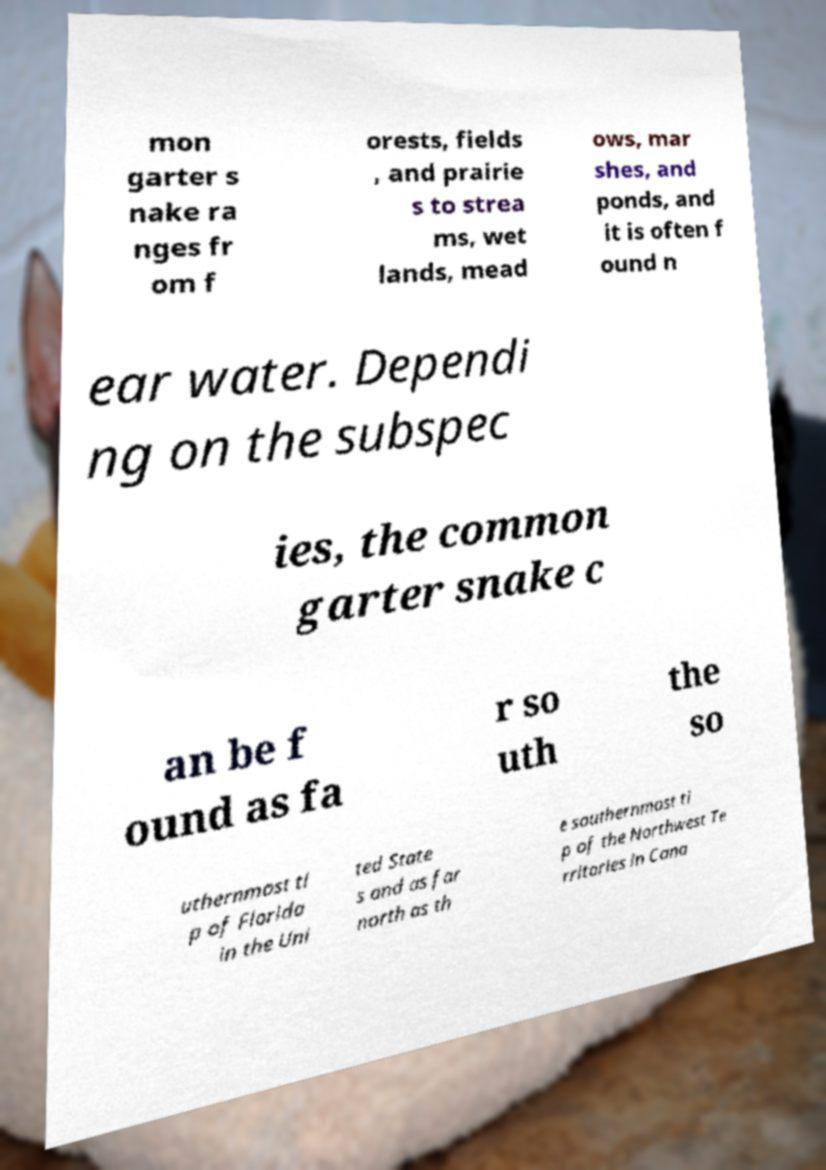Please identify and transcribe the text found in this image. mon garter s nake ra nges fr om f orests, fields , and prairie s to strea ms, wet lands, mead ows, mar shes, and ponds, and it is often f ound n ear water. Dependi ng on the subspec ies, the common garter snake c an be f ound as fa r so uth the so uthernmost ti p of Florida in the Uni ted State s and as far north as th e southernmost ti p of the Northwest Te rritories in Cana 